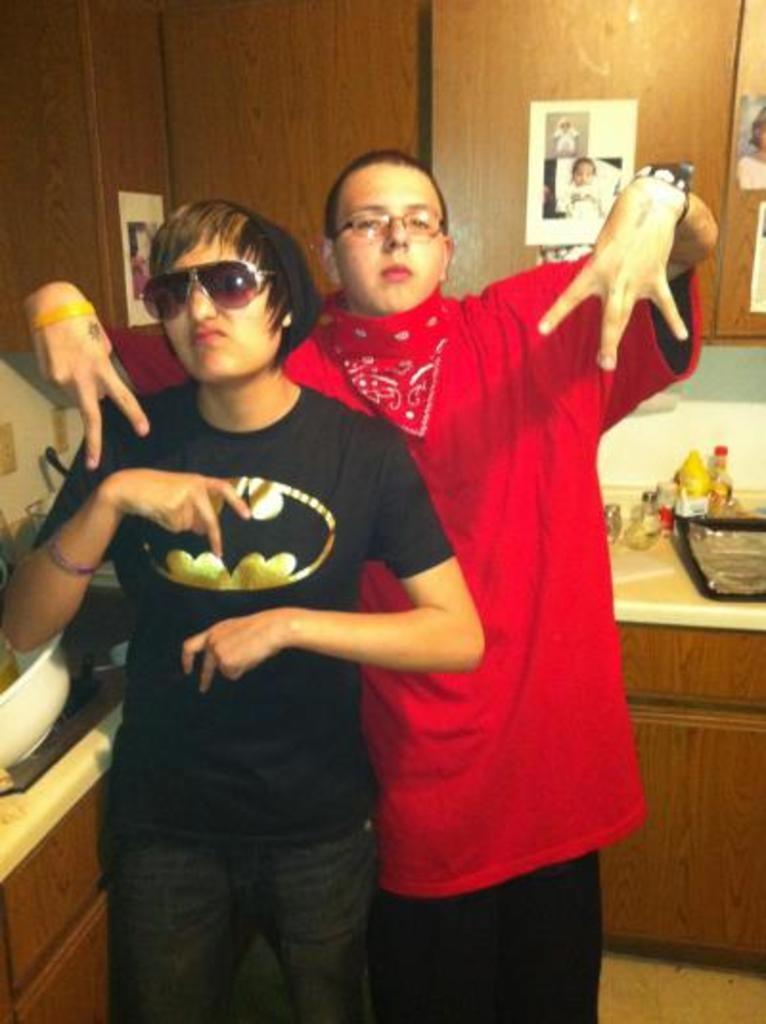How many people are in the image? There are two persons in the image. What can be seen in the background of the image? There are cupboards visible in the background. What is on the shelf in the image? There are objects on the shelf. What is displayed on the cupboards? There are photos on the cupboards. What type of cloth is draped over the pan in the image? There is no pan or cloth present in the image. 